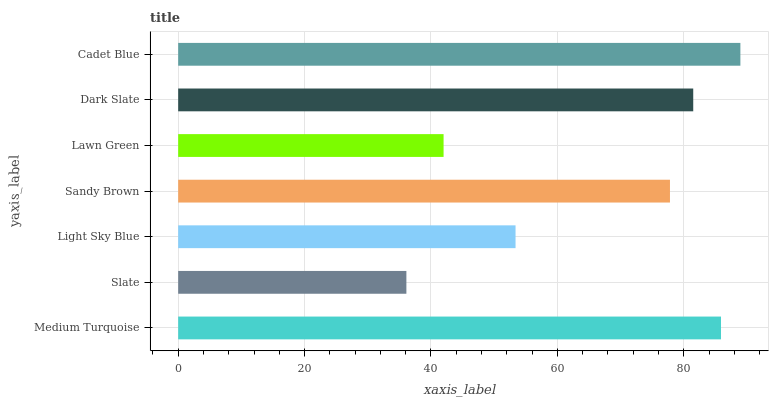Is Slate the minimum?
Answer yes or no. Yes. Is Cadet Blue the maximum?
Answer yes or no. Yes. Is Light Sky Blue the minimum?
Answer yes or no. No. Is Light Sky Blue the maximum?
Answer yes or no. No. Is Light Sky Blue greater than Slate?
Answer yes or no. Yes. Is Slate less than Light Sky Blue?
Answer yes or no. Yes. Is Slate greater than Light Sky Blue?
Answer yes or no. No. Is Light Sky Blue less than Slate?
Answer yes or no. No. Is Sandy Brown the high median?
Answer yes or no. Yes. Is Sandy Brown the low median?
Answer yes or no. Yes. Is Slate the high median?
Answer yes or no. No. Is Slate the low median?
Answer yes or no. No. 